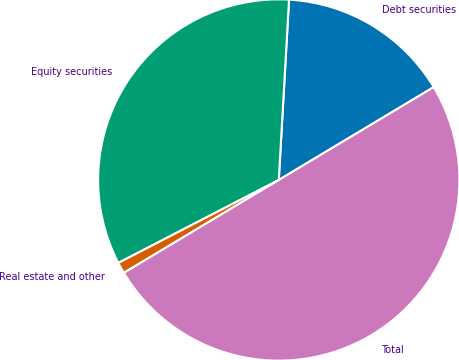Convert chart to OTSL. <chart><loc_0><loc_0><loc_500><loc_500><pie_chart><fcel>Debt securities<fcel>Equity securities<fcel>Real estate and other<fcel>Total<nl><fcel>15.5%<fcel>33.5%<fcel>1.0%<fcel>50.0%<nl></chart> 